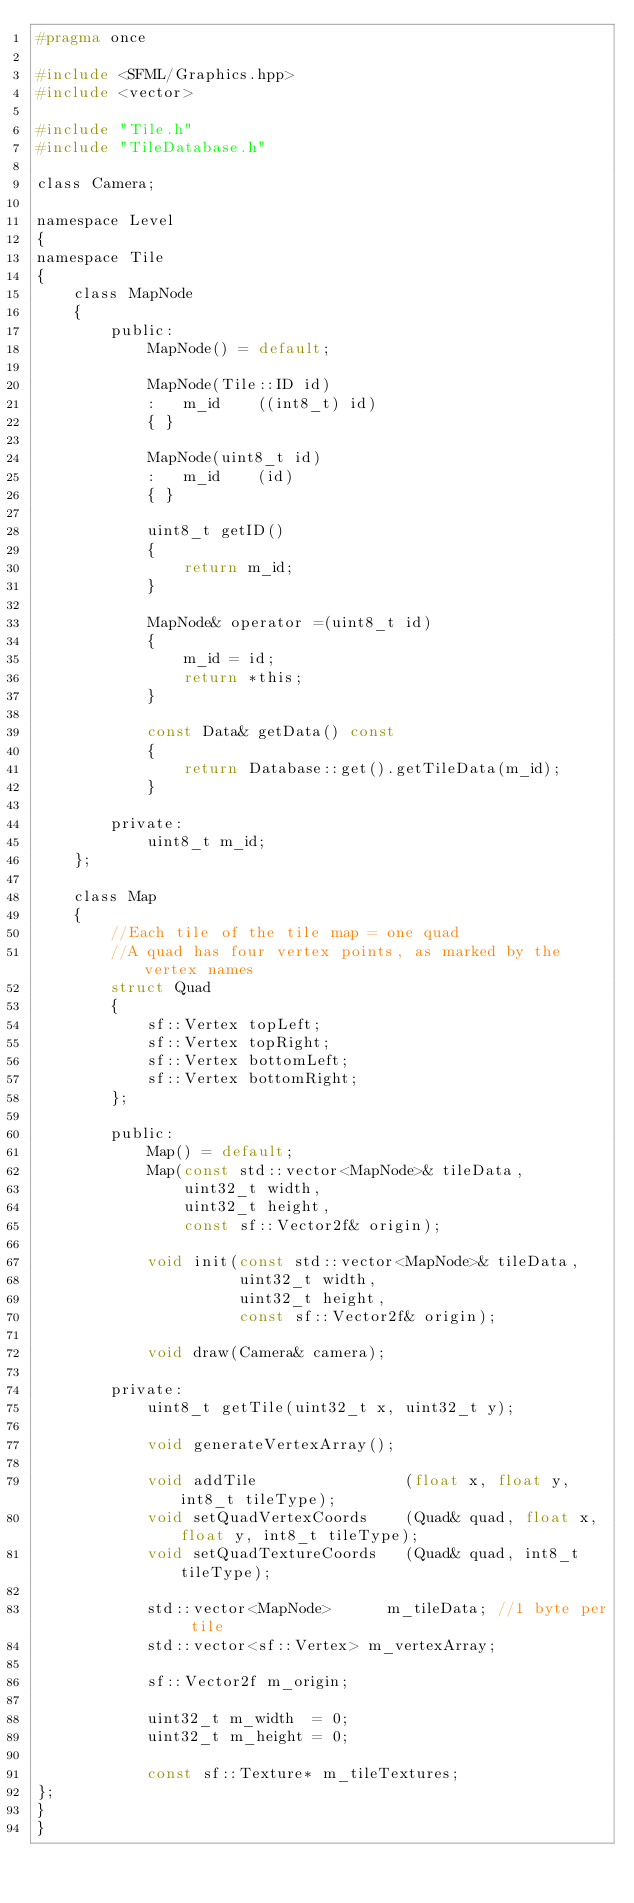<code> <loc_0><loc_0><loc_500><loc_500><_C_>#pragma once

#include <SFML/Graphics.hpp>
#include <vector>

#include "Tile.h"
#include "TileDatabase.h"

class Camera;

namespace Level
{
namespace Tile
{
    class MapNode
    {
        public:
            MapNode() = default;

            MapNode(Tile::ID id)
            :   m_id    ((int8_t) id)
            { }

            MapNode(uint8_t id)
            :   m_id    (id)
            { }

            uint8_t getID()
            {
                return m_id;
            }

            MapNode& operator =(uint8_t id)
            {
                m_id = id;
                return *this;
            }

			const Data& getData() const 
			{
				return Database::get().getTileData(m_id);
			}

        private:
            uint8_t m_id;
    };

    class Map
    {
        //Each tile of the tile map = one quad
        //A quad has four vertex points, as marked by the vertex names
        struct Quad
        {
            sf::Vertex topLeft;
            sf::Vertex topRight;
            sf::Vertex bottomLeft;
            sf::Vertex bottomRight;
        };

        public:
            Map() = default;
            Map(const std::vector<MapNode>& tileData,
                uint32_t width,
                uint32_t height,
                const sf::Vector2f& origin);

            void init(const std::vector<MapNode>& tileData,
                      uint32_t width,
                      uint32_t height,
                      const sf::Vector2f& origin);

            void draw(Camera& camera);

        private:
            uint8_t getTile(uint32_t x, uint32_t y);

            void generateVertexArray();

            void addTile                (float x, float y, int8_t tileType);
            void setQuadVertexCoords    (Quad& quad, float x, float y, int8_t tileType);
            void setQuadTextureCoords   (Quad& quad, int8_t tileType);

            std::vector<MapNode>      m_tileData; //1 byte per tile
            std::vector<sf::Vertex> m_vertexArray;

            sf::Vector2f m_origin;

            uint32_t m_width  = 0;
            uint32_t m_height = 0;

            const sf::Texture* m_tileTextures;
};
}
}
</code> 